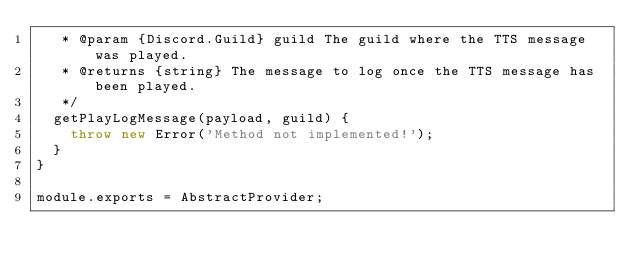Convert code to text. <code><loc_0><loc_0><loc_500><loc_500><_JavaScript_>   * @param {Discord.Guild} guild The guild where the TTS message was played.
   * @returns {string} The message to log once the TTS message has been played.
   */
  getPlayLogMessage(payload, guild) {
    throw new Error('Method not implemented!');
  }
}

module.exports = AbstractProvider;
</code> 